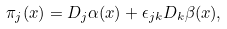<formula> <loc_0><loc_0><loc_500><loc_500>\pi _ { j } ( x ) = D _ { j } \alpha ( x ) + \epsilon _ { j k } D _ { k } \beta ( x ) ,</formula> 